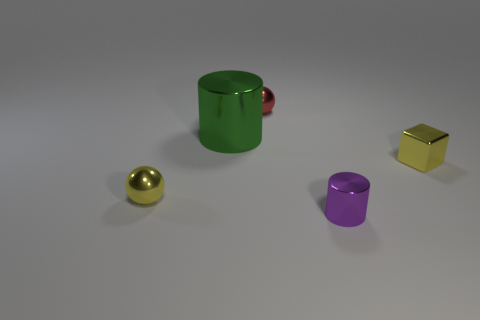Are there more tiny red balls than yellow metal objects?
Provide a succinct answer. No. What color is the tiny shiny cylinder?
Provide a succinct answer. Purple. There is a tiny metal ball behind the tiny yellow shiny block; is its color the same as the metallic block?
Provide a short and direct response. No. There is a ball that is the same color as the tiny block; what material is it?
Give a very brief answer. Metal. How many metal spheres are the same color as the metallic cube?
Your answer should be very brief. 1. Is the shape of the yellow thing that is on the right side of the big green object the same as  the purple object?
Your response must be concise. No. Is the number of small cylinders in front of the purple metal cylinder less than the number of tiny purple metal objects behind the small yellow sphere?
Give a very brief answer. No. What is the small yellow thing left of the purple metallic cylinder made of?
Your answer should be very brief. Metal. The object that is the same color as the small cube is what size?
Provide a short and direct response. Small. Is there a metallic sphere that has the same size as the yellow block?
Keep it short and to the point. Yes. 